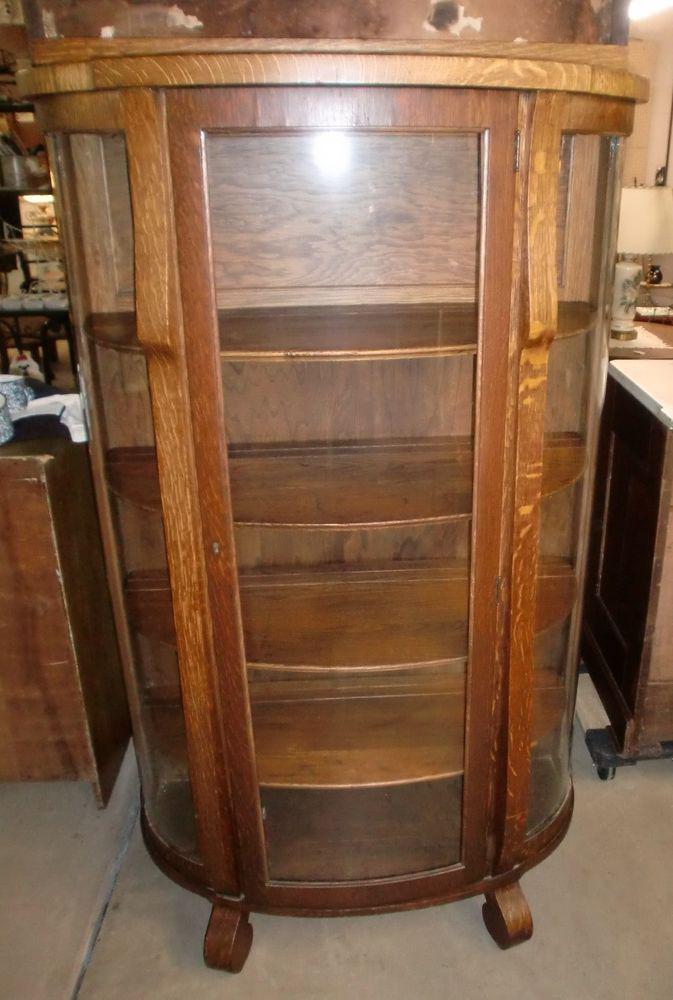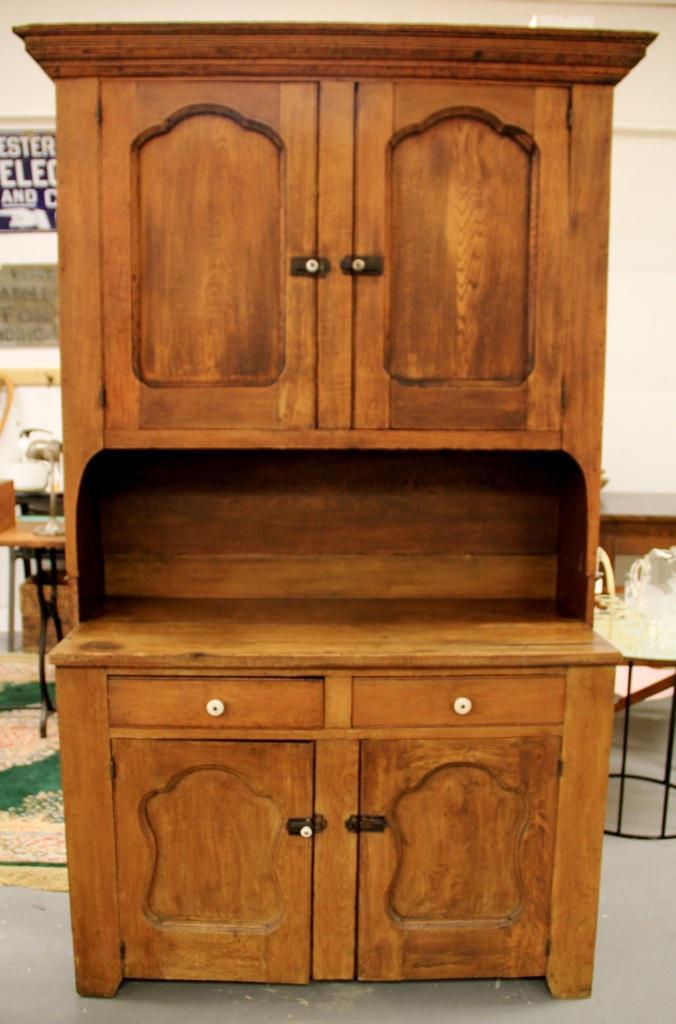The first image is the image on the left, the second image is the image on the right. For the images shown, is this caption "There are two glass doors in the image on the left." true? Answer yes or no. No. The first image is the image on the left, the second image is the image on the right. For the images displayed, is the sentence "Each image shows an empty rectangular hutch with glass upper cabinet doors." factually correct? Answer yes or no. No. 